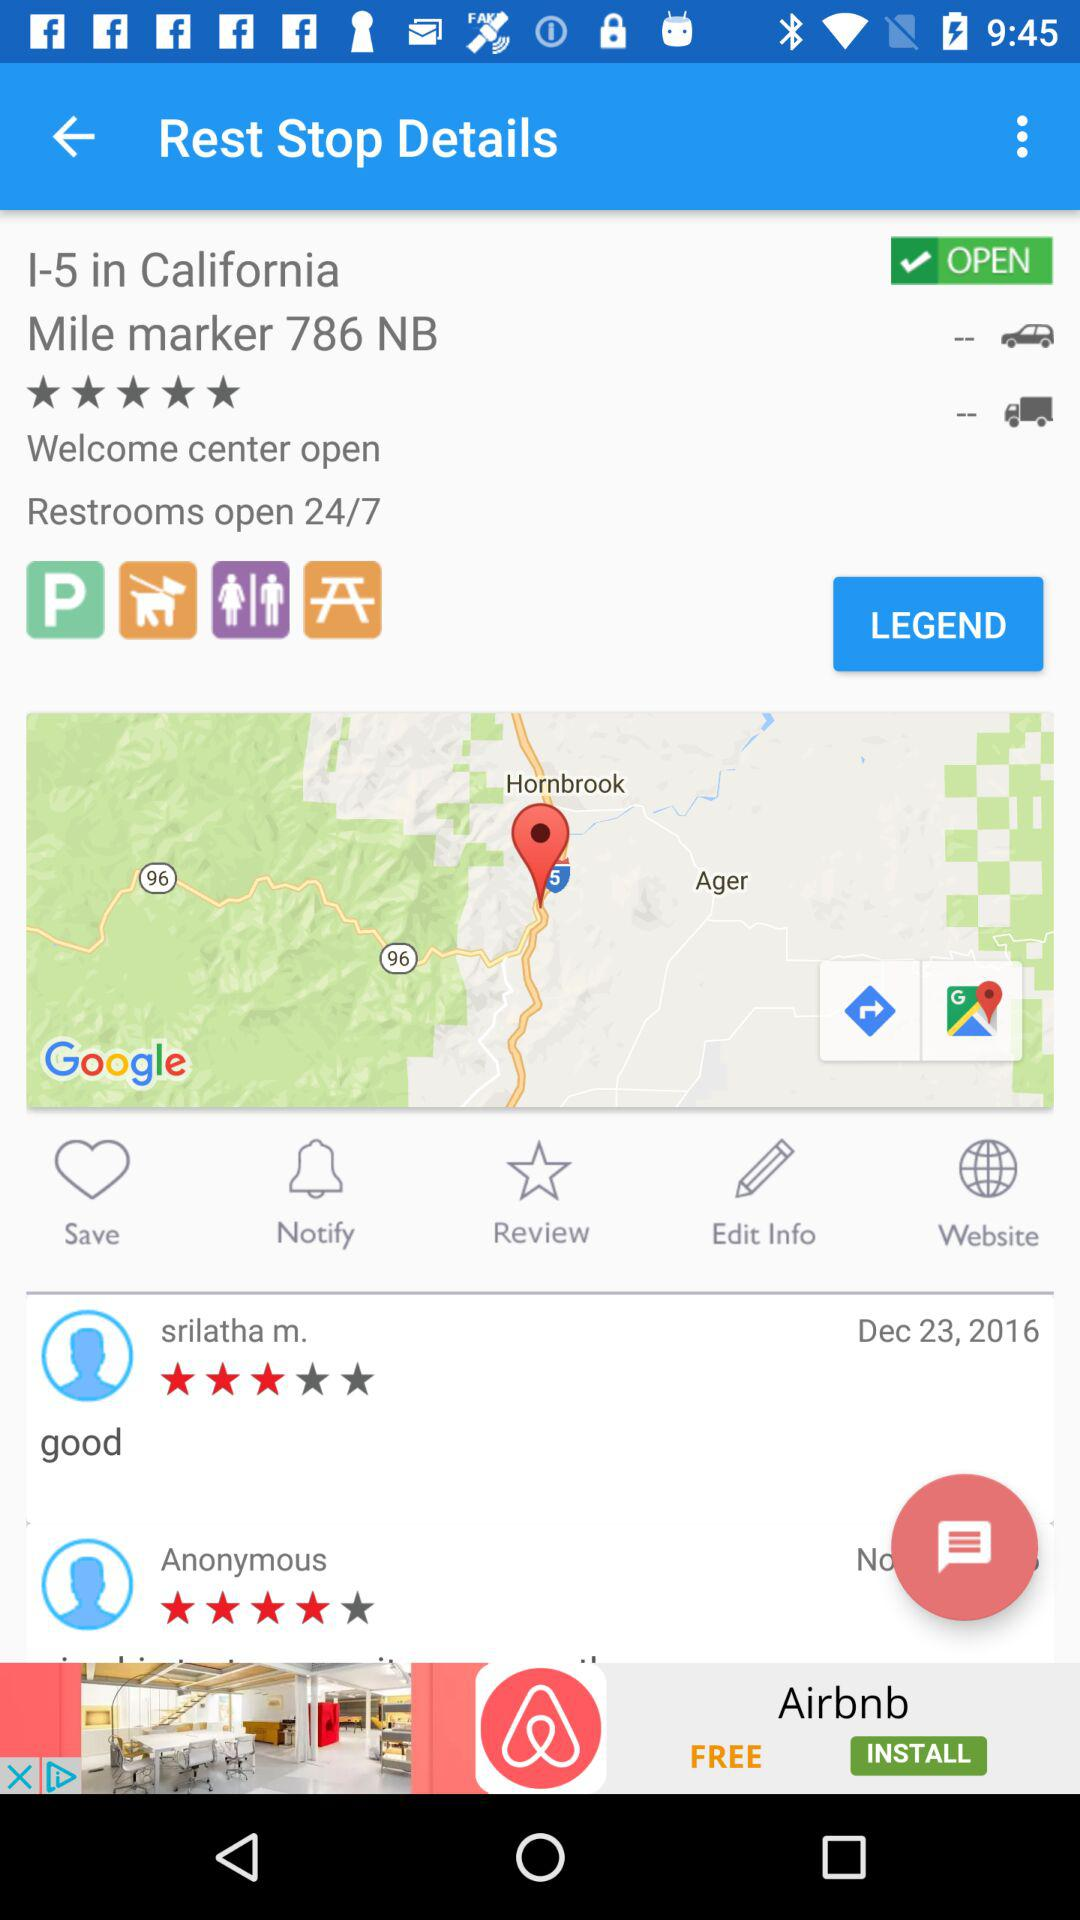On what date did Srilatha M. comment? Srilatha M. commented on December 23, 2016. 